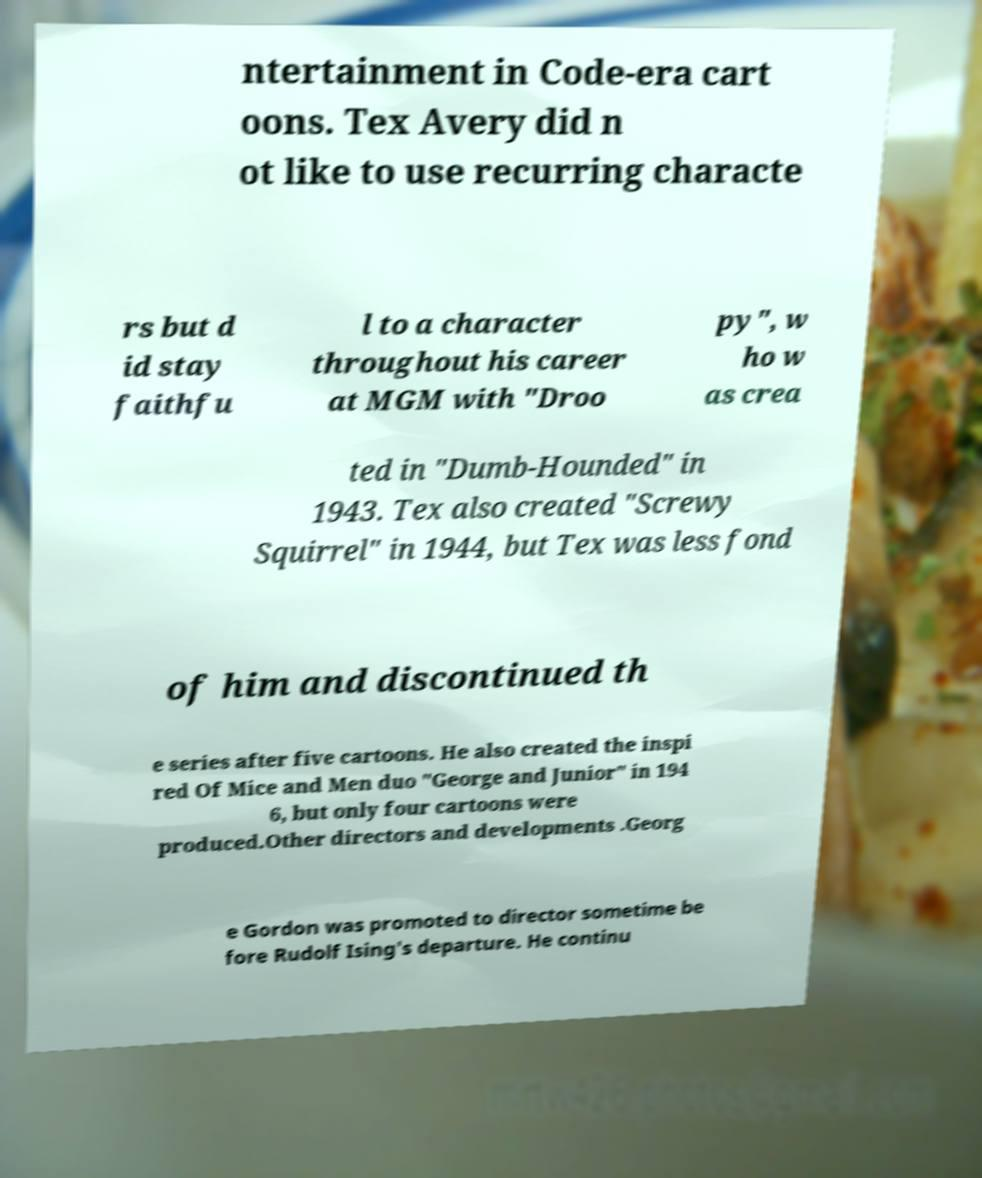Can you accurately transcribe the text from the provided image for me? ntertainment in Code-era cart oons. Tex Avery did n ot like to use recurring characte rs but d id stay faithfu l to a character throughout his career at MGM with "Droo py", w ho w as crea ted in "Dumb-Hounded" in 1943. Tex also created "Screwy Squirrel" in 1944, but Tex was less fond of him and discontinued th e series after five cartoons. He also created the inspi red Of Mice and Men duo "George and Junior" in 194 6, but only four cartoons were produced.Other directors and developments .Georg e Gordon was promoted to director sometime be fore Rudolf Ising's departure. He continu 